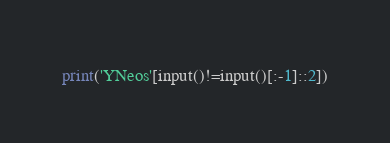Convert code to text. <code><loc_0><loc_0><loc_500><loc_500><_Cython_>print('YNeos'[input()!=input()[:-1]::2])</code> 